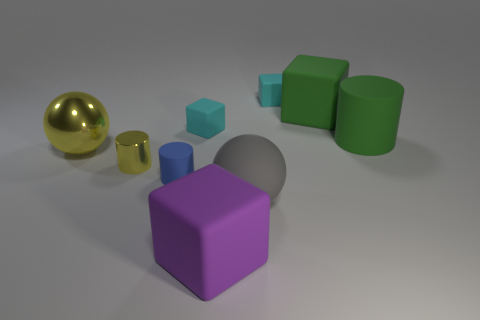How many metal objects are blue cylinders or small cubes?
Your response must be concise. 0. Is the color of the tiny metallic cylinder the same as the large metal object?
Ensure brevity in your answer.  Yes. How many blocks are to the left of the big yellow metal sphere?
Give a very brief answer. 0. What number of large rubber objects are in front of the small blue matte cylinder and behind the purple rubber cube?
Give a very brief answer. 1. What shape is the blue thing that is the same material as the big gray object?
Make the answer very short. Cylinder. Does the yellow metallic thing that is behind the yellow metal cylinder have the same size as the cyan matte block that is behind the big green cube?
Provide a short and direct response. No. There is a sphere behind the tiny blue cylinder; what is its color?
Offer a very short reply. Yellow. There is a green object that is on the right side of the big rubber block that is right of the large gray sphere; what is it made of?
Make the answer very short. Rubber. What is the shape of the big gray thing?
Provide a short and direct response. Sphere. What is the material of the large green thing that is the same shape as the big purple matte object?
Keep it short and to the point. Rubber. 